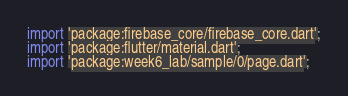Convert code to text. <code><loc_0><loc_0><loc_500><loc_500><_Dart_>import 'package:firebase_core/firebase_core.dart';
import 'package:flutter/material.dart';
import 'package:week6_lab/sample/0/page.dart';</code> 